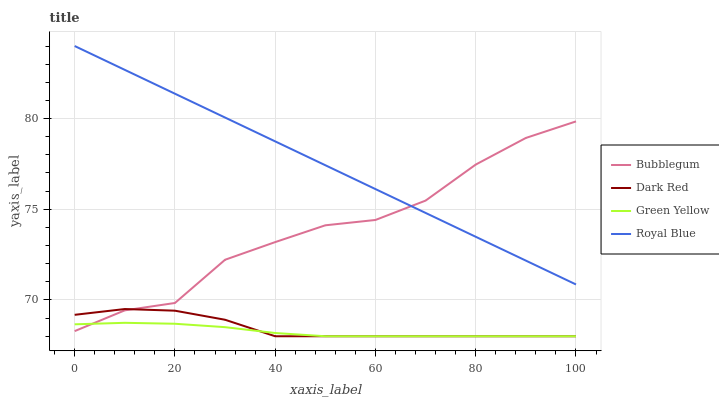Does Green Yellow have the minimum area under the curve?
Answer yes or no. Yes. Does Royal Blue have the maximum area under the curve?
Answer yes or no. Yes. Does Bubblegum have the minimum area under the curve?
Answer yes or no. No. Does Bubblegum have the maximum area under the curve?
Answer yes or no. No. Is Royal Blue the smoothest?
Answer yes or no. Yes. Is Bubblegum the roughest?
Answer yes or no. Yes. Is Green Yellow the smoothest?
Answer yes or no. No. Is Green Yellow the roughest?
Answer yes or no. No. Does Dark Red have the lowest value?
Answer yes or no. Yes. Does Bubblegum have the lowest value?
Answer yes or no. No. Does Royal Blue have the highest value?
Answer yes or no. Yes. Does Bubblegum have the highest value?
Answer yes or no. No. Is Green Yellow less than Royal Blue?
Answer yes or no. Yes. Is Royal Blue greater than Green Yellow?
Answer yes or no. Yes. Does Bubblegum intersect Dark Red?
Answer yes or no. Yes. Is Bubblegum less than Dark Red?
Answer yes or no. No. Is Bubblegum greater than Dark Red?
Answer yes or no. No. Does Green Yellow intersect Royal Blue?
Answer yes or no. No. 